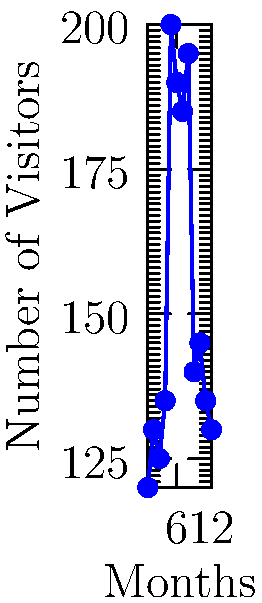The graph shows the number of visitors to the White House over a 12-month period. Which statistical method would be most appropriate to detect the unusual spike in visitors, and what month did this spike occur? To detect unusual patterns in time series data like White House visitor logs, we can follow these steps:

1. Observe the overall trend: The graph shows a relatively stable pattern of visitors between 120-145 per month for most of the year.

2. Identify anomalies: There's a clear spike in visitors around the middle of the year.

3. Choose an appropriate statistical method: For detecting sudden changes or anomalies in time series data, the most suitable method would be:
   - Moving Average (MA) or Exponential Moving Average (EMA) to smooth out short-term fluctuations
   - Control charts (like Shewhart charts) to identify points outside of statistical control
   - CUSUM (Cumulative Sum) charts to detect small shifts in the mean of a process
   - Change Point Detection algorithms to identify abrupt changes in statistical properties

   Among these, Change Point Detection would be most appropriate for identifying a sudden, significant change in the number of visitors.

4. Apply the method: Using Change Point Detection, we would identify the point where the statistical properties of the visitor numbers change significantly.

5. Interpret results: The spike occurs at data point 5, which corresponds to the 5th month (May, assuming January is month 1).
Answer: Change Point Detection; Month 5 (May) 